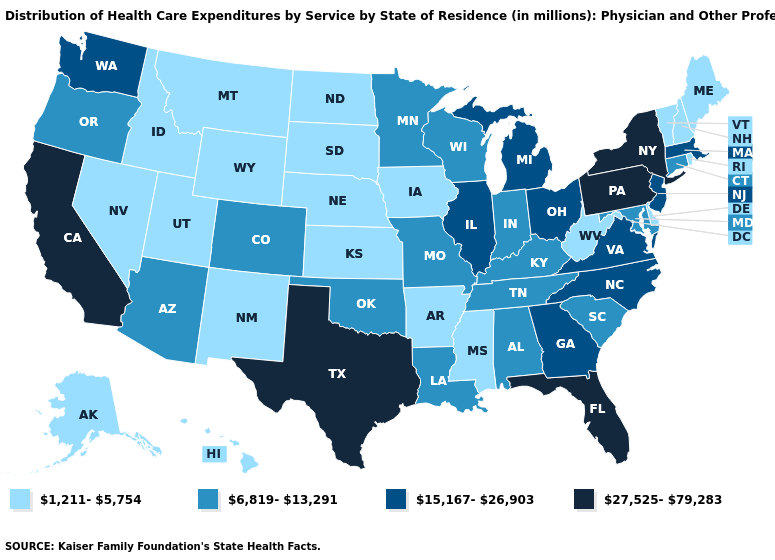What is the value of Mississippi?
Answer briefly. 1,211-5,754. What is the value of New Hampshire?
Keep it brief. 1,211-5,754. What is the value of Utah?
Give a very brief answer. 1,211-5,754. What is the value of New Mexico?
Write a very short answer. 1,211-5,754. What is the value of Connecticut?
Quick response, please. 6,819-13,291. Name the states that have a value in the range 6,819-13,291?
Quick response, please. Alabama, Arizona, Colorado, Connecticut, Indiana, Kentucky, Louisiana, Maryland, Minnesota, Missouri, Oklahoma, Oregon, South Carolina, Tennessee, Wisconsin. Which states have the highest value in the USA?
Write a very short answer. California, Florida, New York, Pennsylvania, Texas. Name the states that have a value in the range 1,211-5,754?
Be succinct. Alaska, Arkansas, Delaware, Hawaii, Idaho, Iowa, Kansas, Maine, Mississippi, Montana, Nebraska, Nevada, New Hampshire, New Mexico, North Dakota, Rhode Island, South Dakota, Utah, Vermont, West Virginia, Wyoming. What is the value of West Virginia?
Concise answer only. 1,211-5,754. Name the states that have a value in the range 1,211-5,754?
Keep it brief. Alaska, Arkansas, Delaware, Hawaii, Idaho, Iowa, Kansas, Maine, Mississippi, Montana, Nebraska, Nevada, New Hampshire, New Mexico, North Dakota, Rhode Island, South Dakota, Utah, Vermont, West Virginia, Wyoming. Is the legend a continuous bar?
Concise answer only. No. What is the lowest value in states that border North Dakota?
Short answer required. 1,211-5,754. What is the value of Arkansas?
Write a very short answer. 1,211-5,754. What is the lowest value in the USA?
Write a very short answer. 1,211-5,754. Does Tennessee have a lower value than New Jersey?
Short answer required. Yes. 